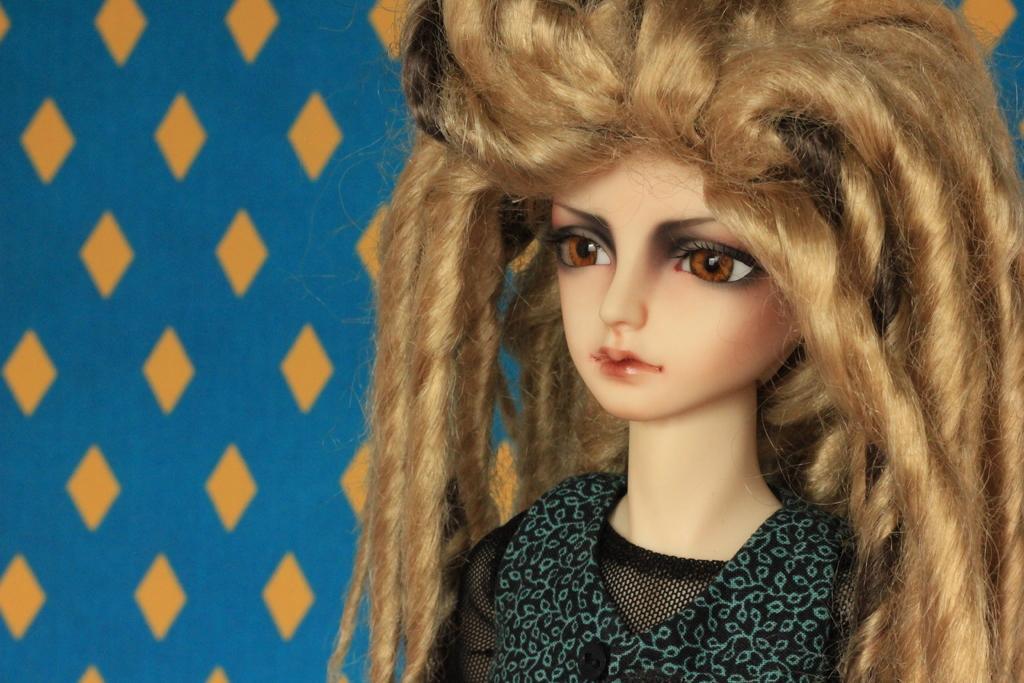Describe this image in one or two sentences. In this image, we can see a doll and the designed wall. 